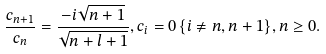<formula> <loc_0><loc_0><loc_500><loc_500>\frac { c _ { n + 1 } } { c _ { n } } = \frac { - i \sqrt { n + 1 } } { \sqrt { n + l + 1 } } , c _ { i } = 0 \, \{ i \neq n , n + 1 \} , n \geq 0 .</formula> 